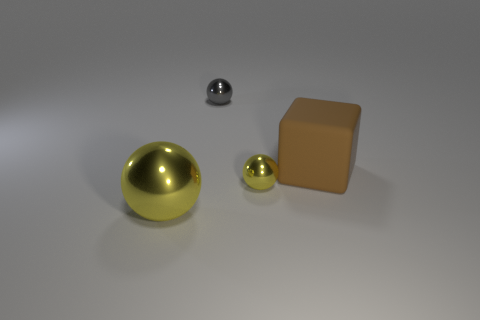Subtract 1 spheres. How many spheres are left? 2 Subtract all small spheres. How many spheres are left? 1 Subtract all blocks. How many objects are left? 3 Add 4 tiny yellow metallic things. How many objects exist? 8 Subtract all gray spheres. Subtract all big cubes. How many objects are left? 2 Add 4 rubber things. How many rubber things are left? 5 Add 2 brown rubber cubes. How many brown rubber cubes exist? 3 Subtract 0 blue cylinders. How many objects are left? 4 